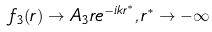<formula> <loc_0><loc_0><loc_500><loc_500>f _ { 3 } ( r ) \rightarrow A _ { 3 } r e ^ { - i k r ^ { * } } , r ^ { * } \rightarrow - \infty</formula> 